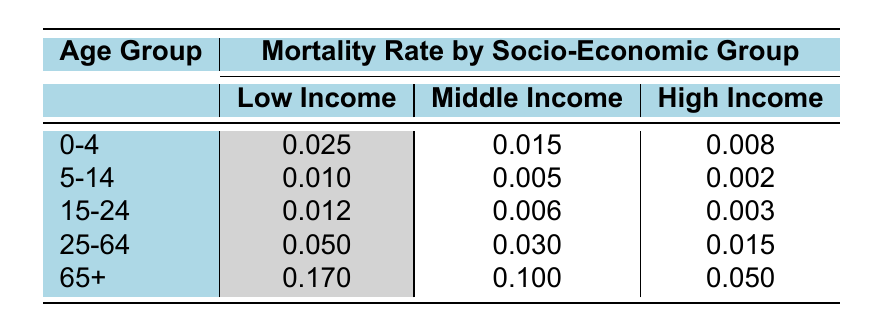What is the mortality rate for the "0-4" age group in the Low Income category? The table directly lists the mortality rate for the "0-4" age group under the Low Income category, which is found in the corresponding cell.
Answer: 0.025 Which socio-economic group has the highest mortality rate in the "25-64" age group? To determine this, we look across the "25-64" row and compare the values for Low Income, Middle Income, and High Income. The value for Low Income is 0.050, which is greater than both Middle Income (0.030) and High Income (0.015).
Answer: Low Income What is the average mortality rate for the High Income group across all age groups? To calculate this, we sum the mortality rates for the High Income group from all age groups: 0.008 + 0.002 + 0.003 + 0.015 + 0.050 = 0.078. Then, we divide this sum by the number of age groups (5): 0.078 / 5 = 0.0156.
Answer: 0.0156 Is the mortality rate for the Middle Income group lower in the "5-14" age group than in the "15-24" age group? Looking at the table, the mortality rate for the Middle Income in the "5-14" age group is 0.005, while in the "15-24" age group, it is 0.006. We can see that 0.005 is less than 0.006, making the statement true.
Answer: Yes What is the difference in mortality rates between Low Income and High Income for the "65+" age group? We locate the mortality rates for the "65+" age group for both socio-economic groups: Low Income has 0.170 and High Income has 0.050. We find the difference by subtracting the High Income rate from the Low Income rate: 0.170 - 0.050 = 0.120.
Answer: 0.120 What is the mortality rate for the Middle Income group in the "0-4" age group? The value for the Middle Income group in the "0-4" age group is directly listed in the table.
Answer: 0.015 Which age group has the lowest mortality rate in the Low Income category? We compare the mortality rates in the Low Income category across all age groups. The lowest value is found with the "5-14" age group at 0.010.
Answer: 5-14 Does the mortality rate for High Income in the "25-64" age group exceed that of Middle Income in the same age group? The table shows that the mortality rate for High Income in the "25-64" age group is 0.015, while for Middle Income, it is 0.030. Since 0.015 is less than 0.030, the statement is false.
Answer: No 